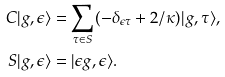<formula> <loc_0><loc_0><loc_500><loc_500>C | g , \epsilon \rangle & = \sum _ { \tau \in S } ( - \delta _ { \epsilon \tau } + 2 / \kappa ) | g , \tau \rangle , \\ S | g , \epsilon \rangle & = | \epsilon g , \epsilon \rangle .</formula> 